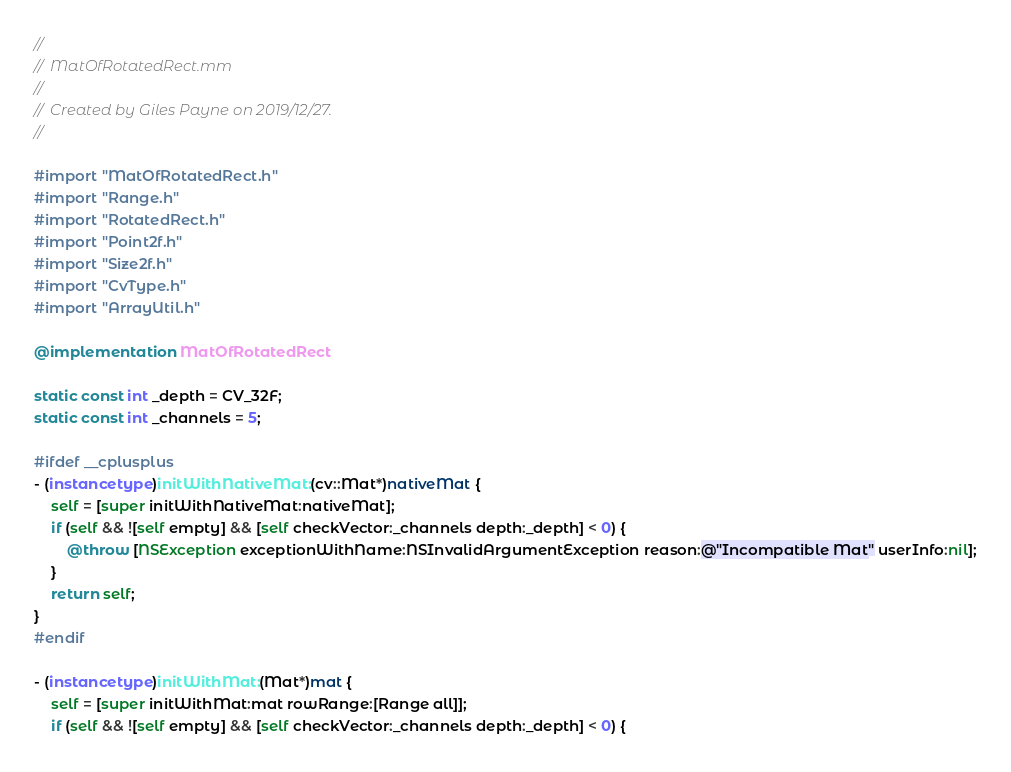Convert code to text. <code><loc_0><loc_0><loc_500><loc_500><_ObjectiveC_>//
//  MatOfRotatedRect.mm
//
//  Created by Giles Payne on 2019/12/27.
//

#import "MatOfRotatedRect.h"
#import "Range.h"
#import "RotatedRect.h"
#import "Point2f.h"
#import "Size2f.h"
#import "CvType.h"
#import "ArrayUtil.h"

@implementation MatOfRotatedRect

static const int _depth = CV_32F;
static const int _channels = 5;

#ifdef __cplusplus
- (instancetype)initWithNativeMat:(cv::Mat*)nativeMat {
    self = [super initWithNativeMat:nativeMat];
    if (self && ![self empty] && [self checkVector:_channels depth:_depth] < 0) {
        @throw [NSException exceptionWithName:NSInvalidArgumentException reason:@"Incompatible Mat" userInfo:nil];
    }
    return self;
}
#endif

- (instancetype)initWithMat:(Mat*)mat {
    self = [super initWithMat:mat rowRange:[Range all]];
    if (self && ![self empty] && [self checkVector:_channels depth:_depth] < 0) {</code> 